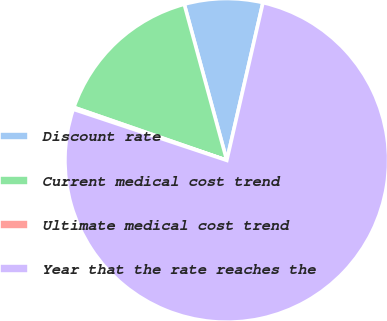Convert chart to OTSL. <chart><loc_0><loc_0><loc_500><loc_500><pie_chart><fcel>Discount rate<fcel>Current medical cost trend<fcel>Ultimate medical cost trend<fcel>Year that the rate reaches the<nl><fcel>7.82%<fcel>15.46%<fcel>0.19%<fcel>76.53%<nl></chart> 